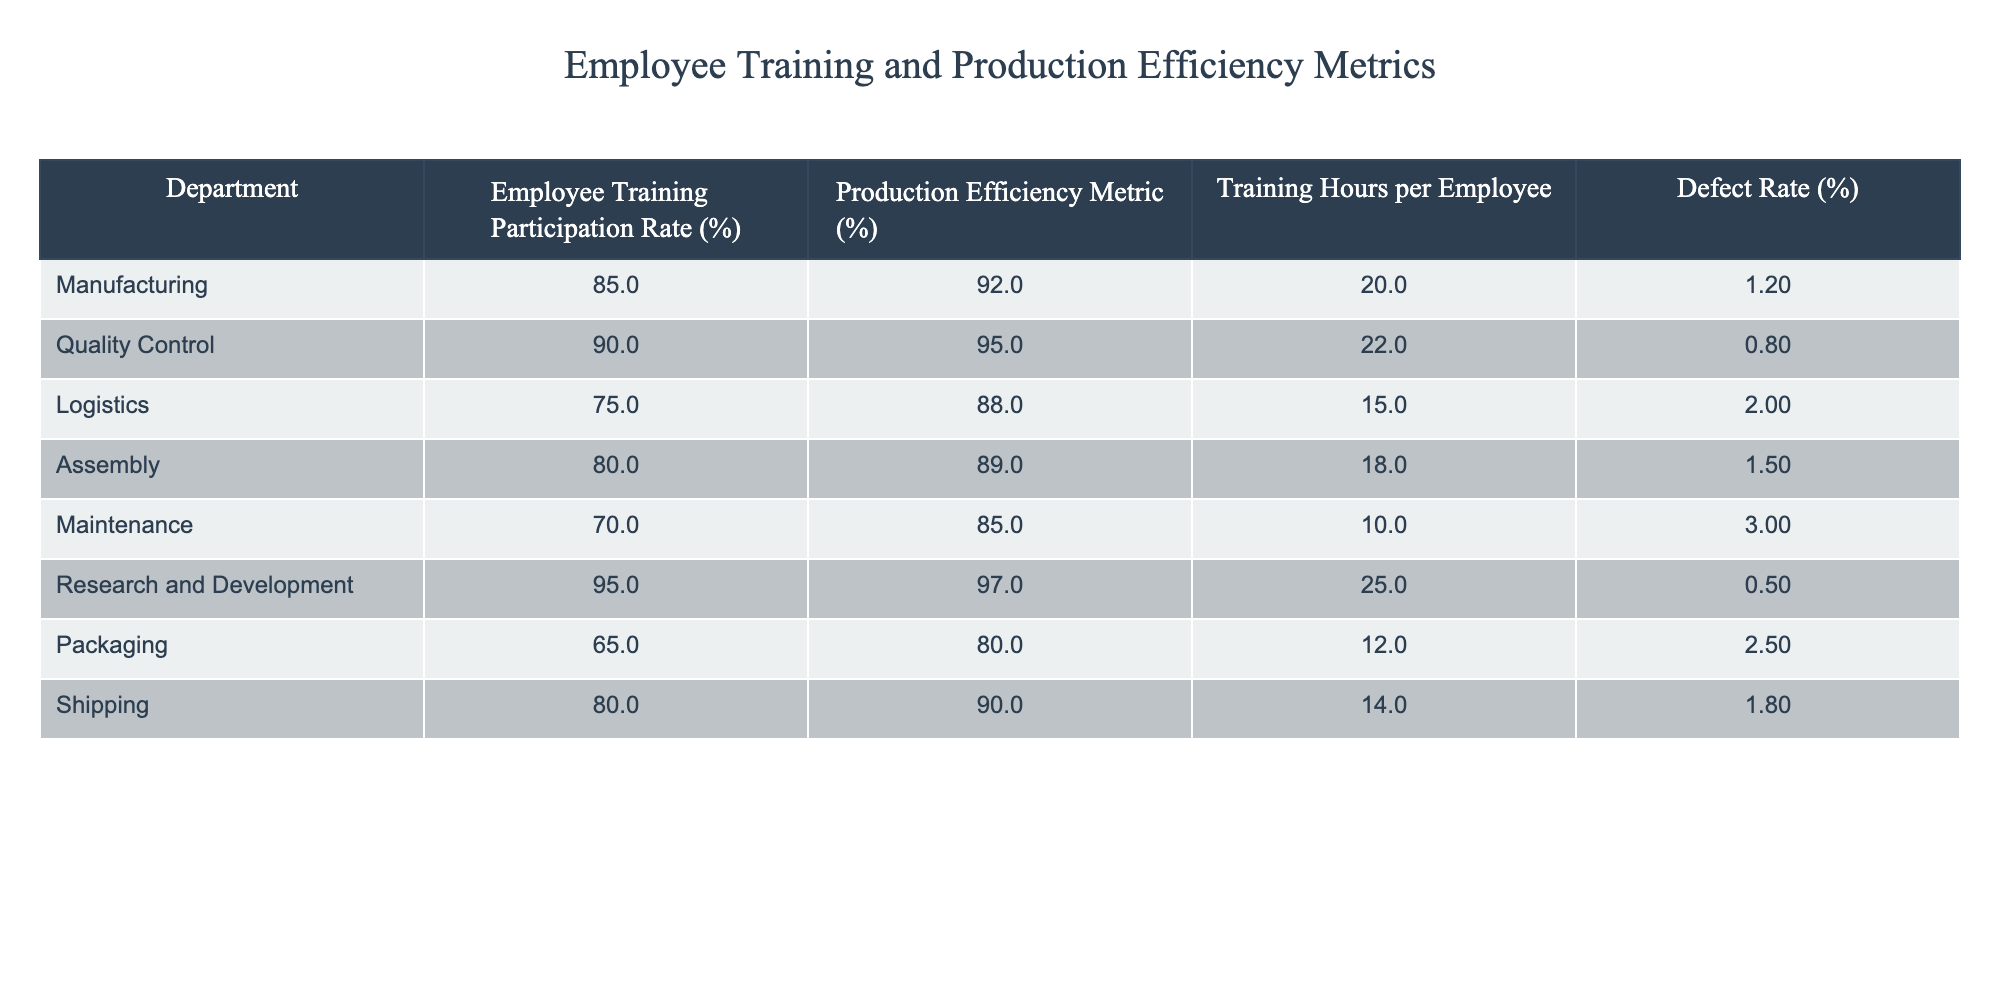What is the employee training participation rate for the Research and Development department? The training participation rate for the Research and Development department is listed in the table as 95%.
Answer: 95% Which department has the highest defect rate? The defect rates for the departments are as follows: Manufacturing (1.2%), Quality Control (0.8%), Logistics (2.0%), Assembly (1.5%), Maintenance (3.0%), Research and Development (0.5%), Packaging (2.5%), and Shipping (1.8%). The highest defect rate is found in the Maintenance department at 3.0%.
Answer: Maintenance What is the average employee training participation rate across all departments? To find the average, we sum the employee training participation rates: (85 + 90 + 75 + 80 + 70 + 95 + 65 + 80) = 730. There are 8 departments, so the average is 730/8 = 91.25%.
Answer: 91.25% Is the Production Efficiency Metric for Quality Control greater than that for Logistics? The Production Efficiency Metric for Quality Control is 95% and for Logistics, it is 88%. Since 95% is greater than 88%, the statement is true.
Answer: Yes Which department has the lowest training hours per employee, and what is that amount? Reviewing the Training Hours per Employee: Manufacturing (20), Quality Control (22), Logistics (15), Assembly (18), Maintenance (10), Research and Development (25), Packaging (12), Shipping (14). The lowest training hours per employee is found in the Maintenance department with 10 hours.
Answer: Maintenance, 10 If we combine the defect rates of the Manufacturing and Assembly departments, what is the sum? The defect rates are as follows: Manufacturing (1.2%) and Assembly (1.5%). Adding these together gives: 1.2 + 1.5 = 2.7%.
Answer: 2.7% How does the employee training participation rate for Packaging compare to that of Shipping? The training participation rate for Packaging is 65% and for Shipping, it is 80%. Since 65% is less than 80%, Packaging has a lower participation rate than Shipping.
Answer: Lower What is the difference between the highest and lowest production efficiency metrics? The highest production efficiency metric is 97% for Research and Development, and the lowest is 80% for Packaging. The difference is: 97 - 80 = 17%.
Answer: 17% Which department has a training participation rate that is exactly 10% lower than that of Quality Control? The training participation rate for Quality Control is 90%. A rate that is 10% lower would be 80%. The department with a training participation rate of 80% is Assembly.
Answer: Assembly 